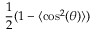Convert formula to latex. <formula><loc_0><loc_0><loc_500><loc_500>\frac { 1 } { 2 } ( 1 - \langle \cos ^ { 2 } ( \theta ) \rangle )</formula> 